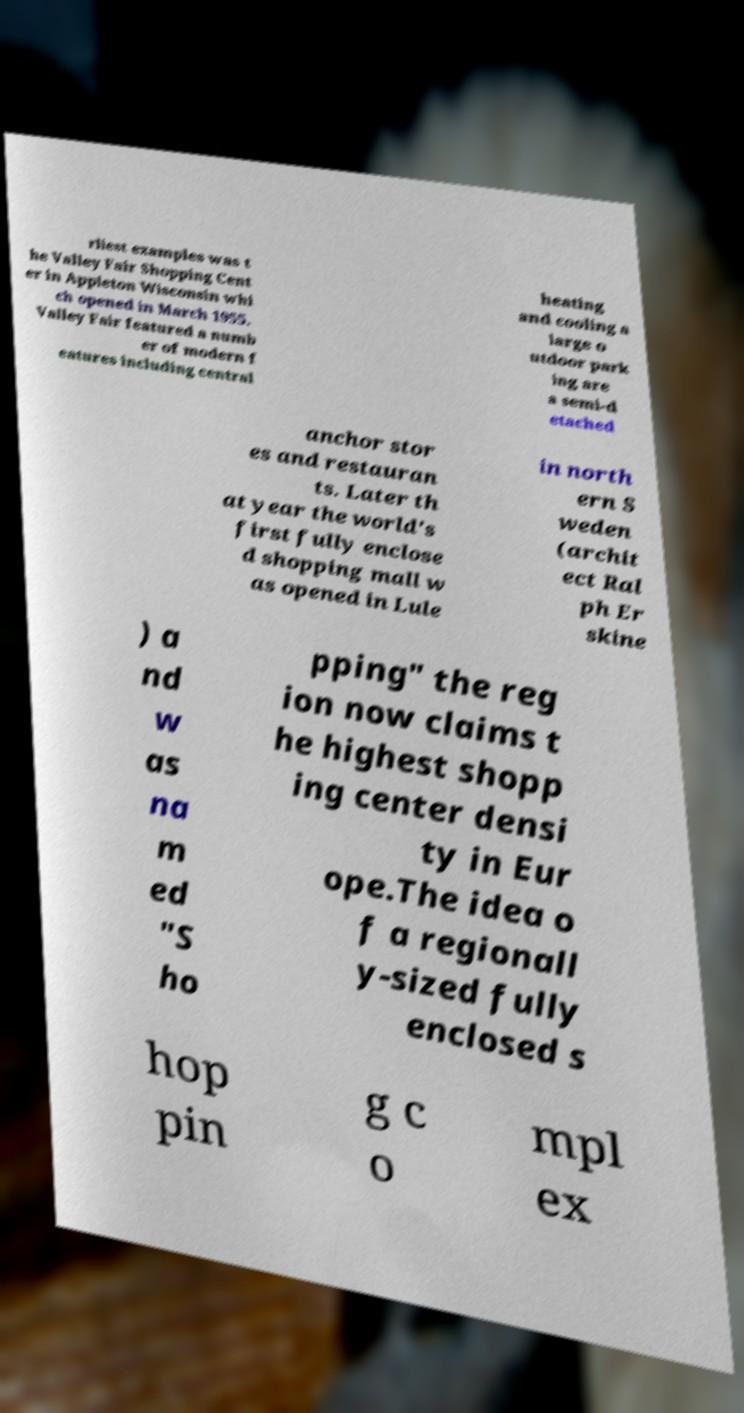Can you accurately transcribe the text from the provided image for me? rliest examples was t he Valley Fair Shopping Cent er in Appleton Wisconsin whi ch opened in March 1955. Valley Fair featured a numb er of modern f eatures including central heating and cooling a large o utdoor park ing are a semi-d etached anchor stor es and restauran ts. Later th at year the world's first fully enclose d shopping mall w as opened in Lule in north ern S weden (archit ect Ral ph Er skine ) a nd w as na m ed "S ho pping" the reg ion now claims t he highest shopp ing center densi ty in Eur ope.The idea o f a regionall y-sized fully enclosed s hop pin g c o mpl ex 